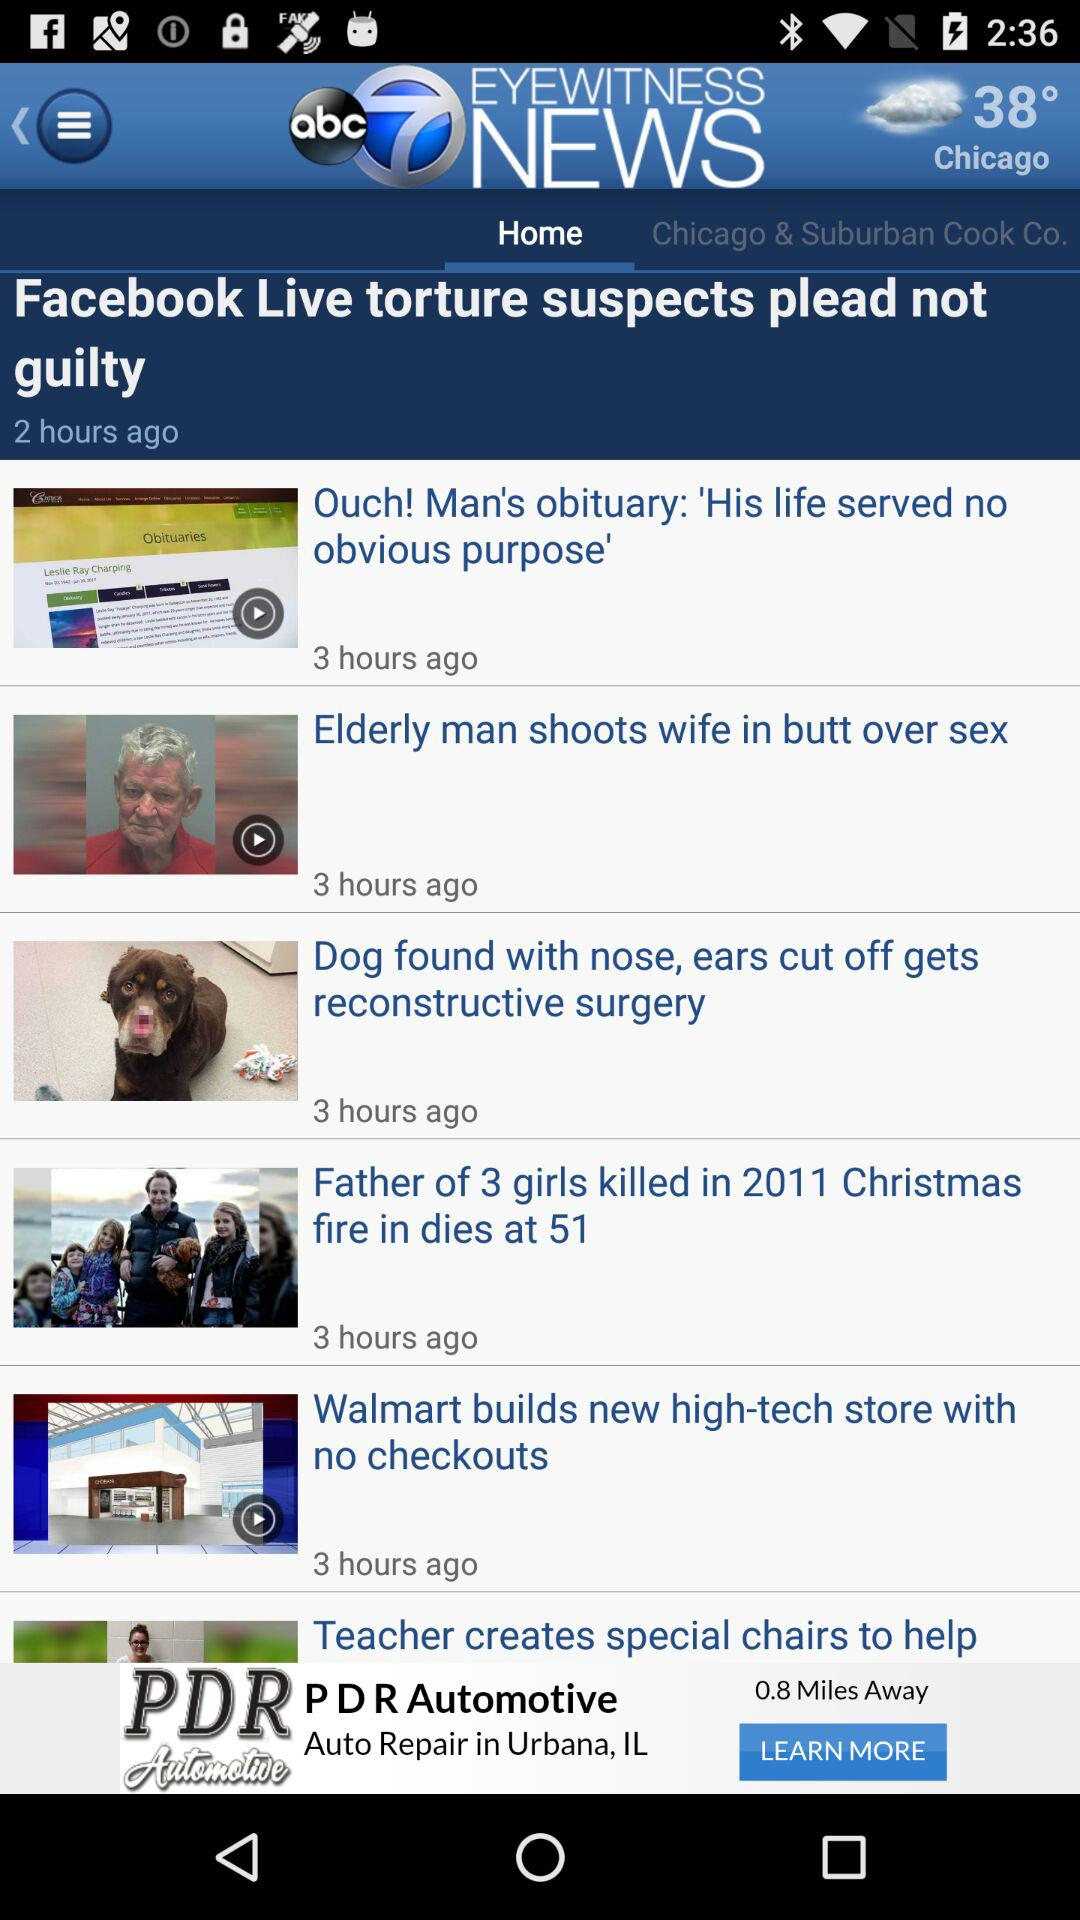How many hours ago was the most recent story published?
Answer the question using a single word or phrase. 3 hours ago 